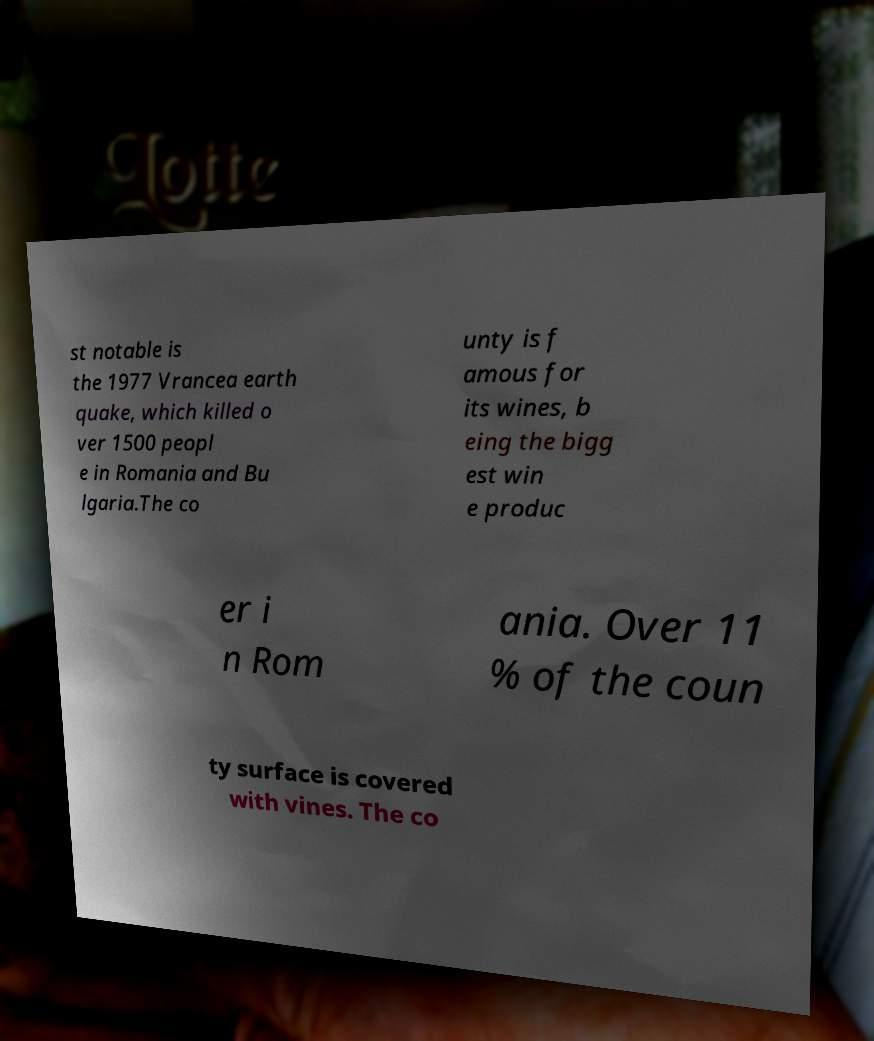Can you accurately transcribe the text from the provided image for me? st notable is the 1977 Vrancea earth quake, which killed o ver 1500 peopl e in Romania and Bu lgaria.The co unty is f amous for its wines, b eing the bigg est win e produc er i n Rom ania. Over 11 % of the coun ty surface is covered with vines. The co 